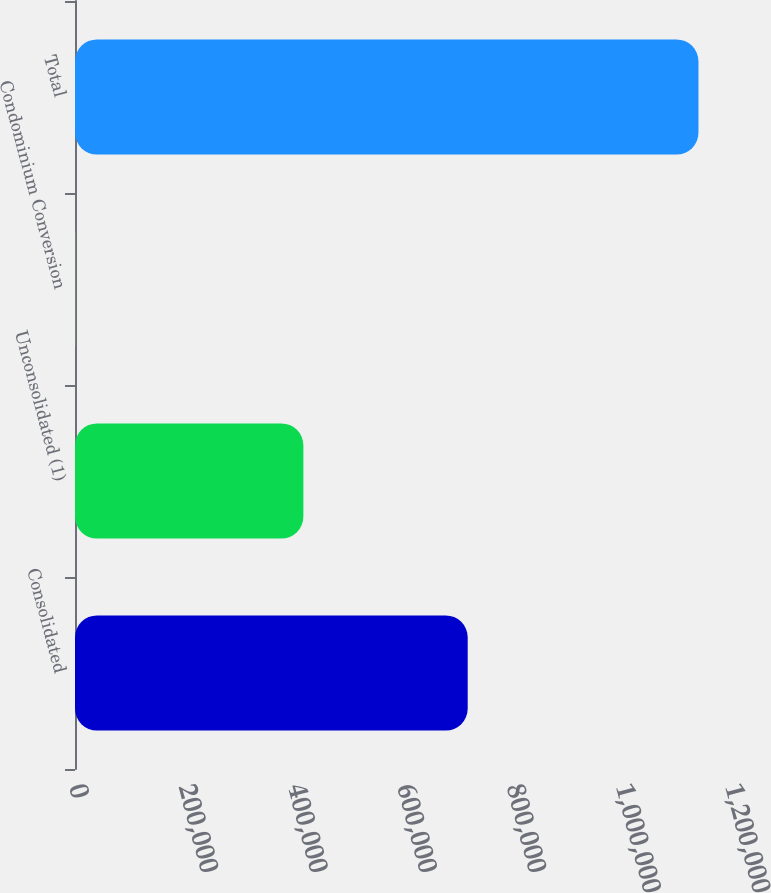Convert chart. <chart><loc_0><loc_0><loc_500><loc_500><bar_chart><fcel>Consolidated<fcel>Unconsolidated (1)<fcel>Condominium Conversion<fcel>Total<nl><fcel>718352<fcel>417779<fcel>360<fcel>1.14049e+06<nl></chart> 